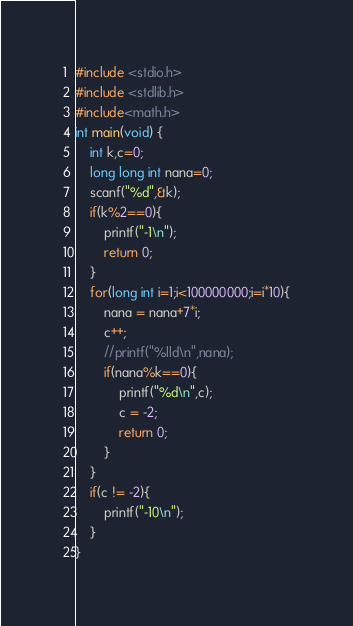Convert code to text. <code><loc_0><loc_0><loc_500><loc_500><_C_>#include <stdio.h>
#include <stdlib.h>
#include<math.h>
int main(void) {
	int k,c=0;
	long long int nana=0;
	scanf("%d",&k);
	if(k%2==0){
		printf("-1\n");
		return 0;
	}
	for(long int i=1;i<100000000;i=i*10){
		nana = nana+7*i;
		c++;
		//printf("%lld\n",nana);
		if(nana%k==0){
			printf("%d\n",c);
			c = -2;
			return 0;
		}
	}
	if(c != -2){
		printf("-10\n");
	}
}
</code> 